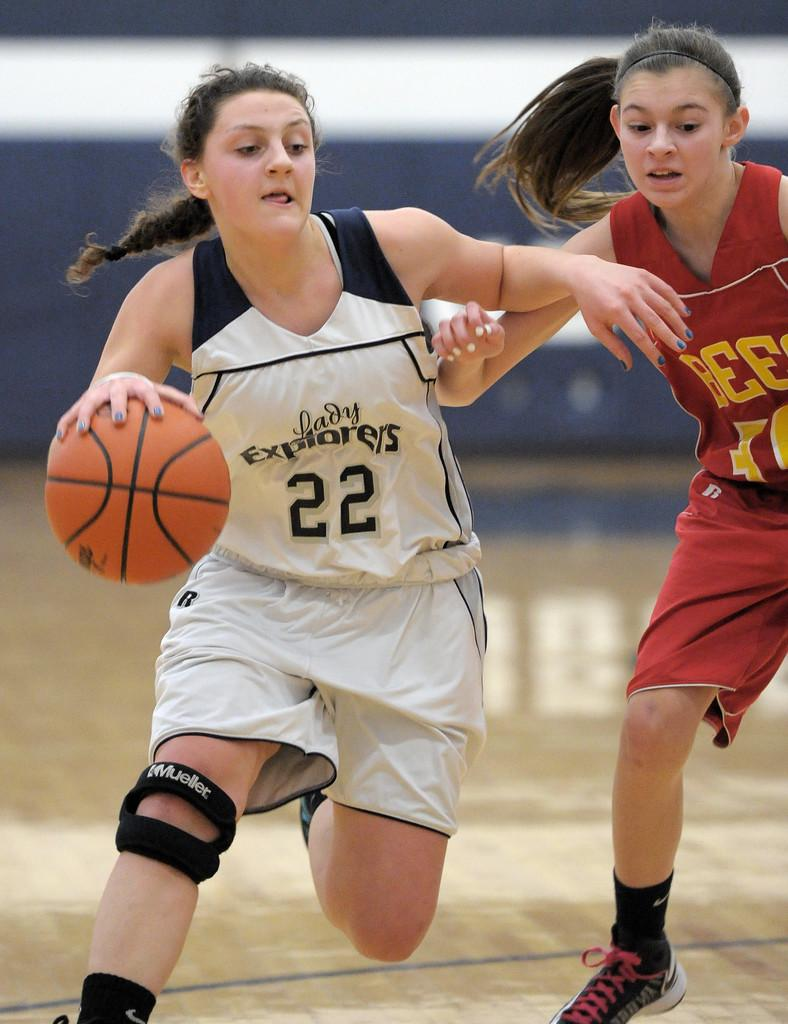<image>
Create a compact narrative representing the image presented. Basketball player for the Explorers dribbling the basketball. 